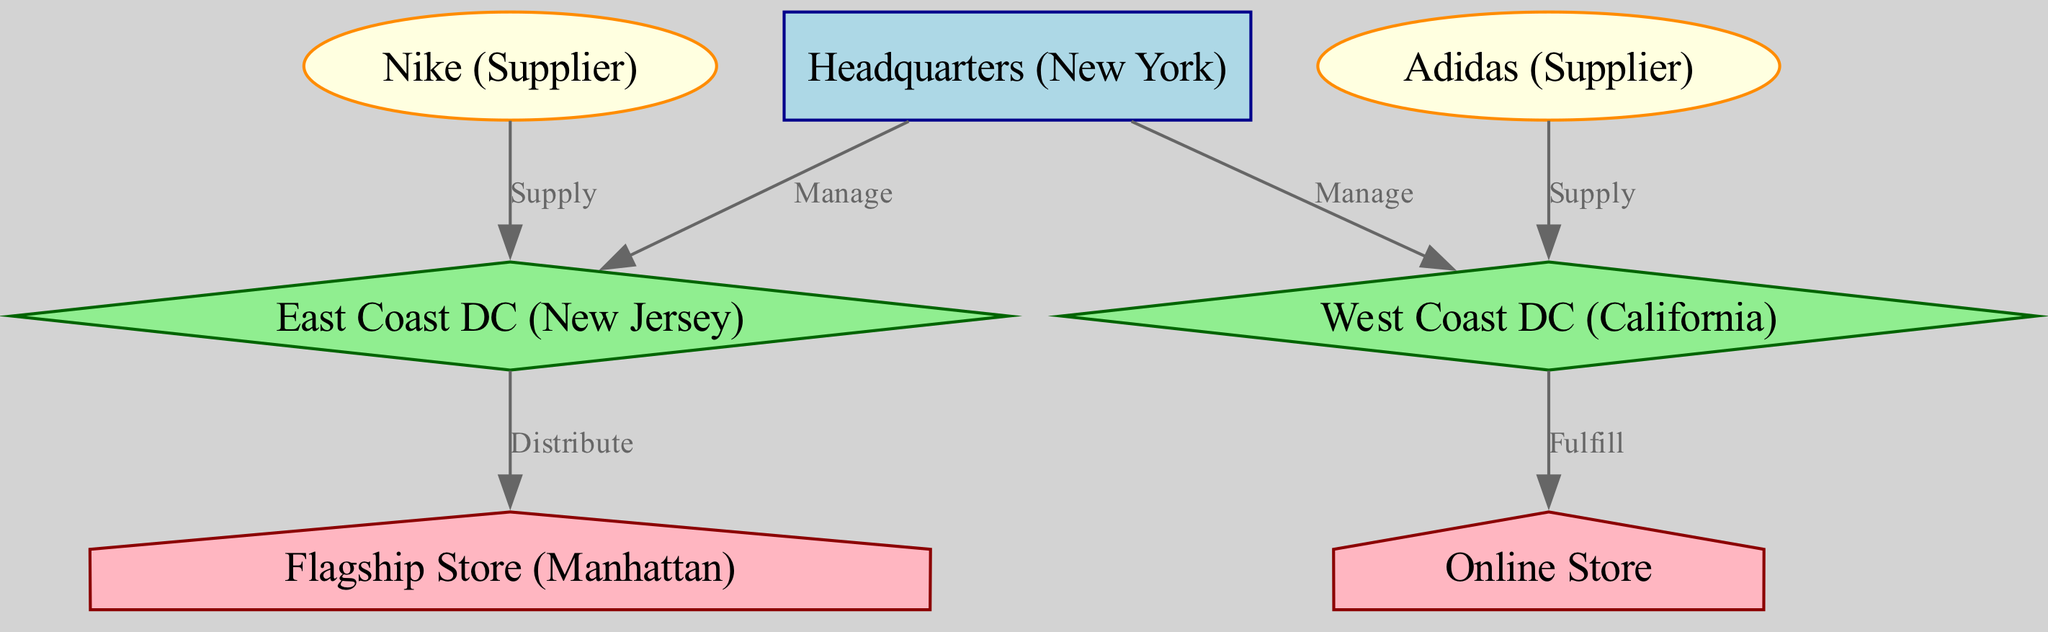What is the type of the node labeled "HQ"? The node labeled "HQ" is identified as the central node in the diagram, which typically represents the headquarters of the organization in this context.
Answer: central How many suppliers are shown in the diagram? The diagram lists two suppliers, Nike and Adidas, as separate nodes connected to their respective distribution centers.
Answer: 2 Which distribution center is managed by the headquarters? The diagram shows that the headquarters manages two distribution centers - East Coast DC and West Coast DC. However, since the question pertains to one, the East Coast DC is explicitly mentioned first in the connections.
Answer: East Coast DC What is the relationship between "DC1" and "R1"? The relationship is indicated by the edge labeled "Distribute," which shows that goods are distributed from the East Coast DC (DC1) to the flagship store (R1).
Answer: Distribute Which supplier supplies the West Coast DC? The edge in the diagram specifies that Adidas (S2) supplies the West Coast DC (DC2), denoting a direct connection between them.
Answer: Adidas How many retail locations are represented in the diagram? The diagram displays two retail locations, namely Flagship Store and Online Store, indicating the points of sale for customers.
Answer: 2 What type of node is "DC2"? The node labeled "DC2" is a distribution center on the West Coast, which is categorized as a distribution type node in the diagram.
Answer: distribution Which node fulfills orders to the Online Store? The diagram specifies that the West Coast DC (DC2) fulfills orders to the Online Store, indicating the direction of goods flow.
Answer: DC2 What kind of node is the "Flagship Store" categorized as? The "Flagship Store" is specifically categorized as a retail node in the diagram, indicating its function in the supply chain.
Answer: retail 